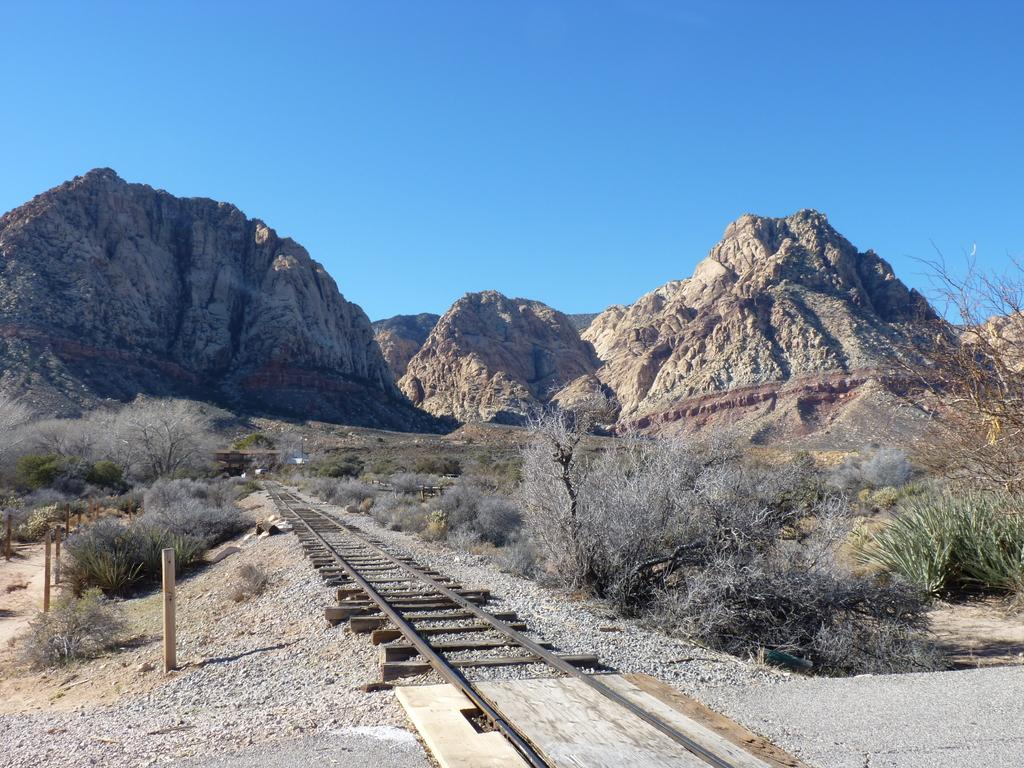What type of surface can be seen in the image? There is a track in the image. What type of vegetation is present in the image? There are plants and dried trees in the image. What type of structures can be seen in the image? There are wooden poles in the image. What can be seen in the background of the image? There are hills and a blue sky visible in the background of the image. What type of drum can be seen in the image? There is no drum present in the image. What is the image framed within? The image is not framed within any specific object or structure. 